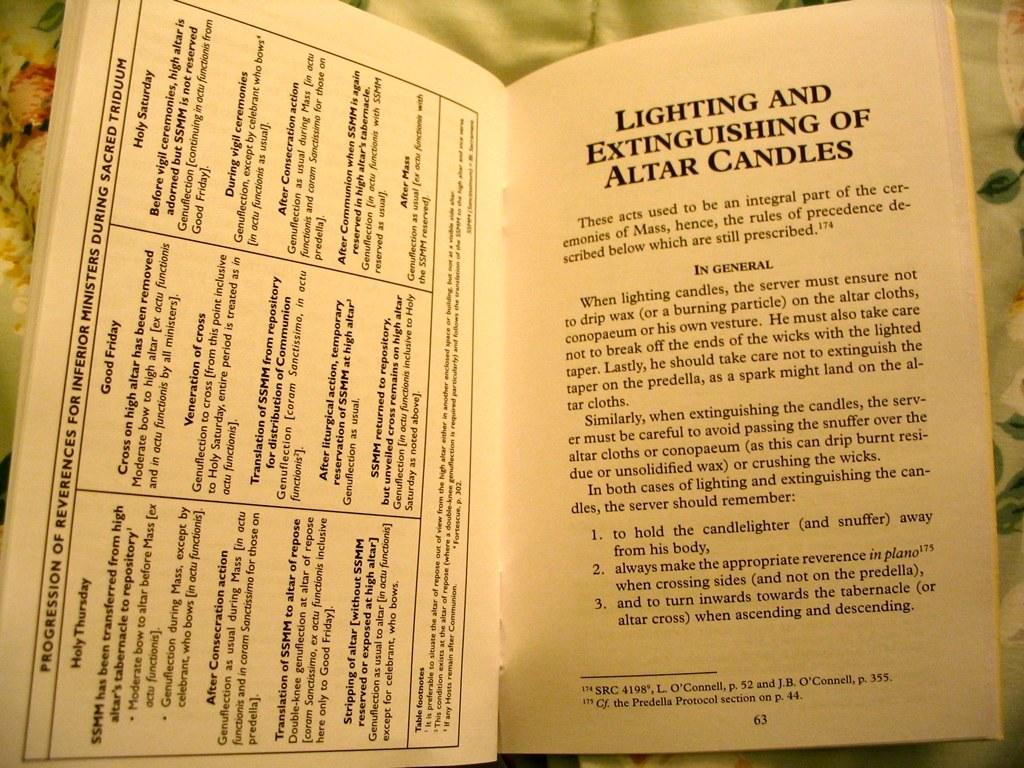What is the page number?
Make the answer very short. 63. 